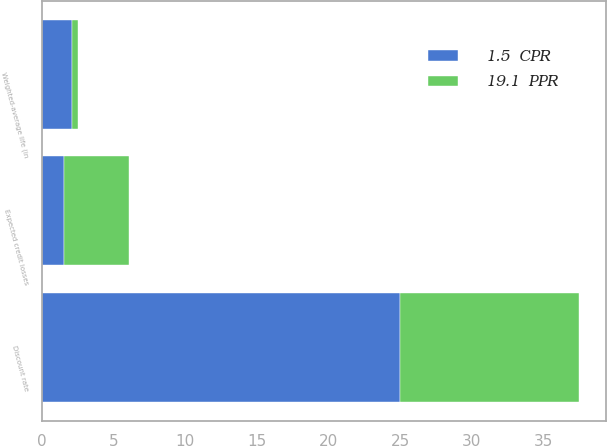Convert chart. <chart><loc_0><loc_0><loc_500><loc_500><stacked_bar_chart><ecel><fcel>Weighted-average life (in<fcel>Expected credit losses<fcel>Discount rate<nl><fcel>19.1  PPR<fcel>0.4<fcel>4.6<fcel>12.5<nl><fcel>1.5  CPR<fcel>2.1<fcel>1.5<fcel>25<nl></chart> 